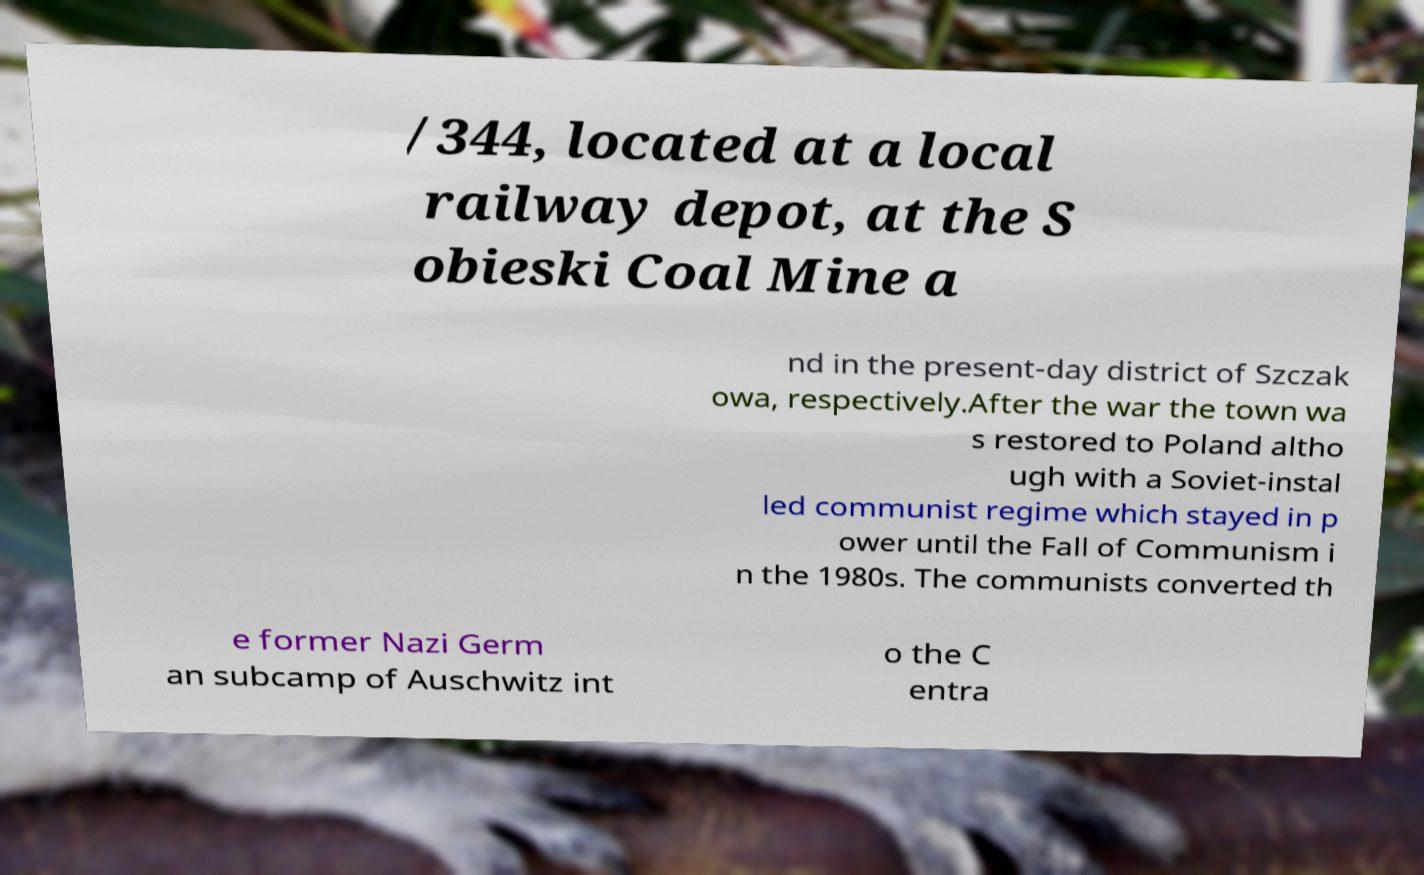Please identify and transcribe the text found in this image. /344, located at a local railway depot, at the S obieski Coal Mine a nd in the present-day district of Szczak owa, respectively.After the war the town wa s restored to Poland altho ugh with a Soviet-instal led communist regime which stayed in p ower until the Fall of Communism i n the 1980s. The communists converted th e former Nazi Germ an subcamp of Auschwitz int o the C entra 